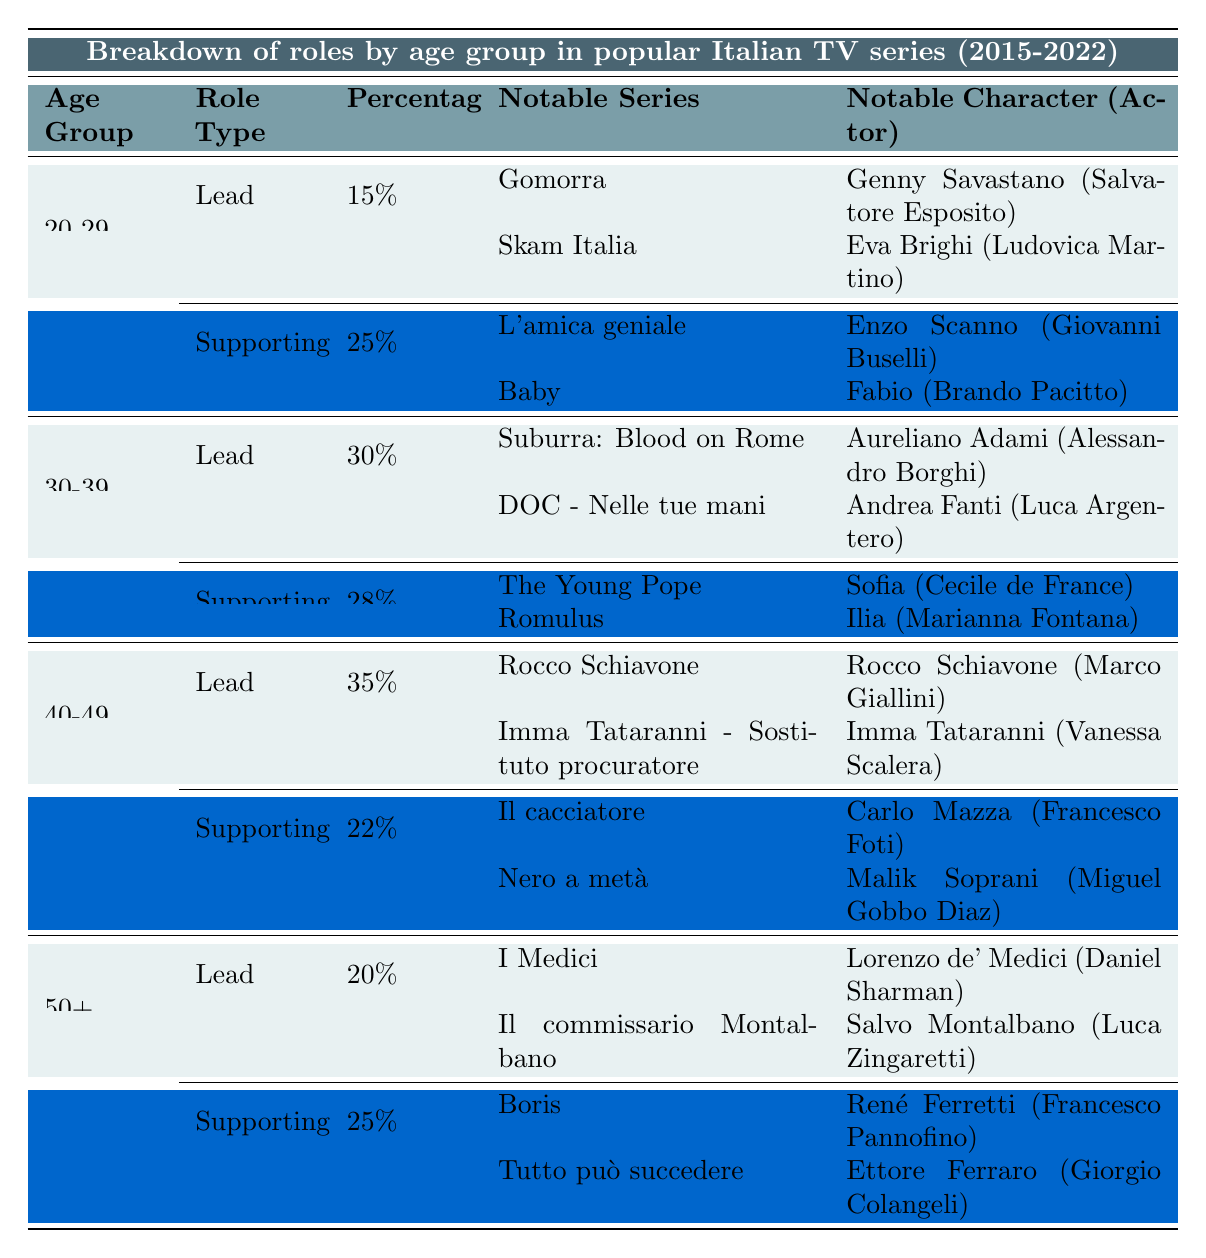What is the percentage of lead roles for the age group 30-39? The table indicates that for the age group 30-39, the percentage of lead roles is listed under the "Roles" section, where it shows 30%.
Answer: 30% Which age group has the highest percentage of supporting roles? By looking at the supporting roles percentages across age groups, 50+ has a percentage of 25%, while 40-49 has 22%. The highest supporting role percentage is in the age group 20-29 with 25%.
Answer: 20-29 What is the notable series for the lead role in the 50+ age group? The table lists the lead roles for the 50+ age group, featuring "I Medici" and "Il commissario Montalbano."
Answer: I Medici, Il commissario Montalbano For the age group 40-49, what is the difference in percentage between lead and supporting roles? The lead role percentage is 35%, and the supporting role percentage is 22% for the age group 40-49. The difference can be calculated by subtracting the supporting percentage from the lead percentage: 35% - 22% = 13%.
Answer: 13% Are there any notable characters played by women in the lead roles across all age groups? Reviewing the table, there are no notable female characters listed in the lead roles for all age groups. All notable examples for lead roles are male characters.
Answer: No What is the total percentage of lead roles across all age groups? The percentages for lead roles are 15% (20-29), 30% (30-39), 35% (40-49), and 20% (50+). Adding these gives: 15% + 30% + 35% + 20% = 100%.
Answer: 100% In which series does the character "Enzo Scanno" appear, and what is his role type? The character "Enzo Scanno" is in "L'amica geniale," and his role is categorized as supporting, as per the table.
Answer: Supporting in L'amica geniale How many notable examples for lead roles are listed for the age group 30-39? The table shows there are two notable examples listed for lead roles in the age group 30-39: "Aureliano Adami" in "Suburra: Blood on Rome" and "Andrea Fanti" in "DOC - Nelle tue mani."
Answer: 2 Which character in the 40-49 age group has the highest supporting role percentage, and what is that percentage? For the age group 40-49, the supporting role percentage is 22%. The characters listed, "Carlo Mazza" in "Il cacciatore" and "Malik Soprani" in "Nero a metà," share this same percentage, which is the highest for supporting roles in that age group.
Answer: 22% 